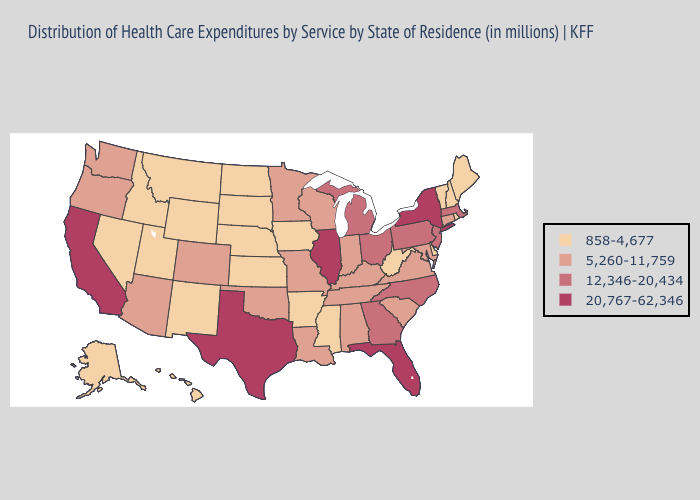How many symbols are there in the legend?
Give a very brief answer. 4. What is the highest value in the USA?
Be succinct. 20,767-62,346. Name the states that have a value in the range 20,767-62,346?
Answer briefly. California, Florida, Illinois, New York, Texas. What is the lowest value in states that border California?
Short answer required. 858-4,677. Does Oregon have the same value as Rhode Island?
Short answer required. No. What is the value of Massachusetts?
Quick response, please. 12,346-20,434. Name the states that have a value in the range 12,346-20,434?
Short answer required. Georgia, Massachusetts, Michigan, New Jersey, North Carolina, Ohio, Pennsylvania. Name the states that have a value in the range 858-4,677?
Concise answer only. Alaska, Arkansas, Delaware, Hawaii, Idaho, Iowa, Kansas, Maine, Mississippi, Montana, Nebraska, Nevada, New Hampshire, New Mexico, North Dakota, Rhode Island, South Dakota, Utah, Vermont, West Virginia, Wyoming. Does the map have missing data?
Quick response, please. No. Does the map have missing data?
Short answer required. No. Is the legend a continuous bar?
Concise answer only. No. Which states hav the highest value in the MidWest?
Quick response, please. Illinois. What is the highest value in states that border New Hampshire?
Short answer required. 12,346-20,434. Name the states that have a value in the range 858-4,677?
Answer briefly. Alaska, Arkansas, Delaware, Hawaii, Idaho, Iowa, Kansas, Maine, Mississippi, Montana, Nebraska, Nevada, New Hampshire, New Mexico, North Dakota, Rhode Island, South Dakota, Utah, Vermont, West Virginia, Wyoming. 